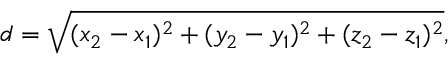Convert formula to latex. <formula><loc_0><loc_0><loc_500><loc_500>d = { \sqrt { ( x _ { 2 } - x _ { 1 } ) ^ { 2 } + ( y _ { 2 } - y _ { 1 } ) ^ { 2 } + ( z _ { 2 } - z _ { 1 } ) ^ { 2 } } } ,</formula> 